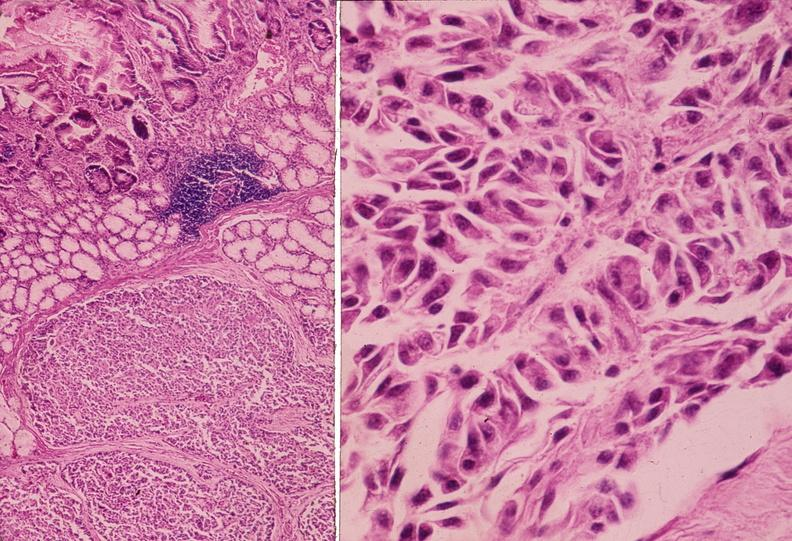does temporal muscle hemorrhage show islet cell tumor, zollinger ellison syndrome?
Answer the question using a single word or phrase. No 